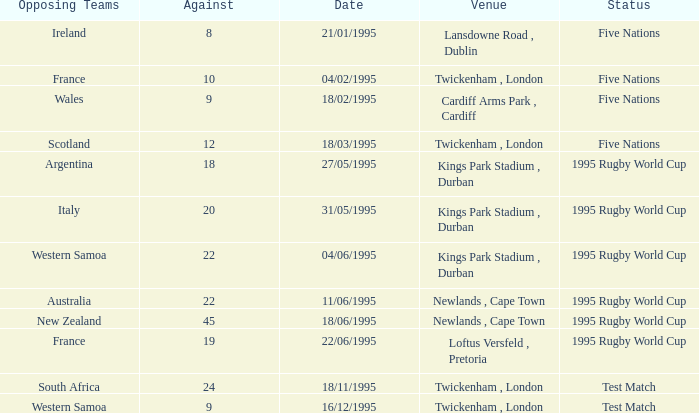What date has a status of 1995 rugby world cup and an against of 20? 31/05/1995. 